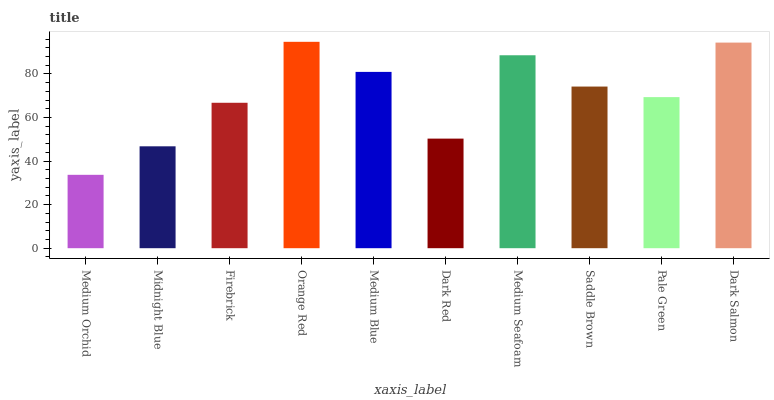Is Medium Orchid the minimum?
Answer yes or no. Yes. Is Orange Red the maximum?
Answer yes or no. Yes. Is Midnight Blue the minimum?
Answer yes or no. No. Is Midnight Blue the maximum?
Answer yes or no. No. Is Midnight Blue greater than Medium Orchid?
Answer yes or no. Yes. Is Medium Orchid less than Midnight Blue?
Answer yes or no. Yes. Is Medium Orchid greater than Midnight Blue?
Answer yes or no. No. Is Midnight Blue less than Medium Orchid?
Answer yes or no. No. Is Saddle Brown the high median?
Answer yes or no. Yes. Is Pale Green the low median?
Answer yes or no. Yes. Is Orange Red the high median?
Answer yes or no. No. Is Medium Orchid the low median?
Answer yes or no. No. 